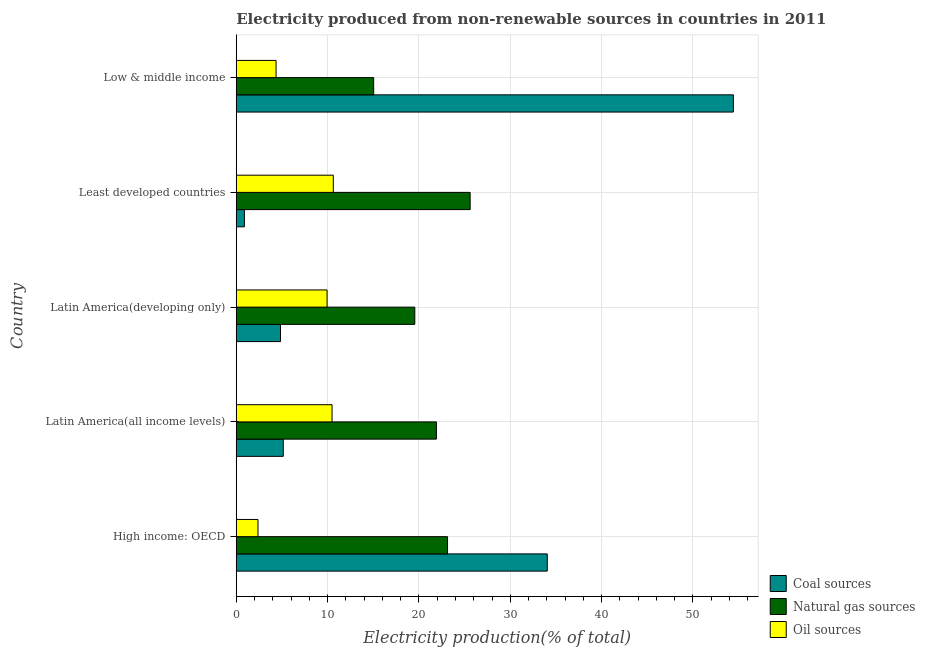How many different coloured bars are there?
Your answer should be compact. 3. How many bars are there on the 3rd tick from the bottom?
Your answer should be very brief. 3. What is the label of the 4th group of bars from the top?
Provide a short and direct response. Latin America(all income levels). What is the percentage of electricity produced by coal in Latin America(all income levels)?
Provide a succinct answer. 5.15. Across all countries, what is the maximum percentage of electricity produced by natural gas?
Your answer should be very brief. 25.61. Across all countries, what is the minimum percentage of electricity produced by natural gas?
Your response must be concise. 15.04. In which country was the percentage of electricity produced by natural gas maximum?
Your response must be concise. Least developed countries. In which country was the percentage of electricity produced by oil sources minimum?
Your response must be concise. High income: OECD. What is the total percentage of electricity produced by oil sources in the graph?
Provide a succinct answer. 37.79. What is the difference between the percentage of electricity produced by coal in Latin America(all income levels) and that in Low & middle income?
Provide a succinct answer. -49.28. What is the difference between the percentage of electricity produced by oil sources in Latin America(developing only) and the percentage of electricity produced by coal in Latin America(all income levels)?
Ensure brevity in your answer.  4.79. What is the average percentage of electricity produced by natural gas per country?
Offer a terse response. 21.05. What is the difference between the percentage of electricity produced by natural gas and percentage of electricity produced by coal in Low & middle income?
Keep it short and to the point. -39.38. What is the ratio of the percentage of electricity produced by natural gas in Latin America(all income levels) to that in Low & middle income?
Provide a short and direct response. 1.46. Is the percentage of electricity produced by natural gas in Latin America(all income levels) less than that in Least developed countries?
Provide a succinct answer. Yes. Is the difference between the percentage of electricity produced by natural gas in High income: OECD and Latin America(all income levels) greater than the difference between the percentage of electricity produced by oil sources in High income: OECD and Latin America(all income levels)?
Your answer should be compact. Yes. What is the difference between the highest and the second highest percentage of electricity produced by natural gas?
Keep it short and to the point. 2.48. What is the difference between the highest and the lowest percentage of electricity produced by natural gas?
Provide a short and direct response. 10.56. In how many countries, is the percentage of electricity produced by natural gas greater than the average percentage of electricity produced by natural gas taken over all countries?
Your answer should be compact. 3. Is the sum of the percentage of electricity produced by oil sources in Latin America(all income levels) and Latin America(developing only) greater than the maximum percentage of electricity produced by natural gas across all countries?
Offer a very short reply. No. What does the 1st bar from the top in Low & middle income represents?
Offer a very short reply. Oil sources. What does the 2nd bar from the bottom in High income: OECD represents?
Make the answer very short. Natural gas sources. How many bars are there?
Ensure brevity in your answer.  15. Are all the bars in the graph horizontal?
Offer a very short reply. Yes. How many countries are there in the graph?
Give a very brief answer. 5. What is the difference between two consecutive major ticks on the X-axis?
Ensure brevity in your answer.  10. Are the values on the major ticks of X-axis written in scientific E-notation?
Offer a very short reply. No. Does the graph contain grids?
Provide a succinct answer. Yes. How are the legend labels stacked?
Ensure brevity in your answer.  Vertical. What is the title of the graph?
Offer a very short reply. Electricity produced from non-renewable sources in countries in 2011. What is the label or title of the X-axis?
Offer a terse response. Electricity production(% of total). What is the label or title of the Y-axis?
Provide a short and direct response. Country. What is the Electricity production(% of total) of Coal sources in High income: OECD?
Provide a short and direct response. 34.05. What is the Electricity production(% of total) of Natural gas sources in High income: OECD?
Offer a very short reply. 23.13. What is the Electricity production(% of total) in Oil sources in High income: OECD?
Offer a very short reply. 2.38. What is the Electricity production(% of total) of Coal sources in Latin America(all income levels)?
Offer a very short reply. 5.15. What is the Electricity production(% of total) in Natural gas sources in Latin America(all income levels)?
Provide a short and direct response. 21.91. What is the Electricity production(% of total) in Oil sources in Latin America(all income levels)?
Your answer should be compact. 10.49. What is the Electricity production(% of total) in Coal sources in Latin America(developing only)?
Your answer should be very brief. 4.84. What is the Electricity production(% of total) in Natural gas sources in Latin America(developing only)?
Provide a short and direct response. 19.55. What is the Electricity production(% of total) in Oil sources in Latin America(developing only)?
Provide a short and direct response. 9.94. What is the Electricity production(% of total) in Coal sources in Least developed countries?
Make the answer very short. 0.89. What is the Electricity production(% of total) in Natural gas sources in Least developed countries?
Your answer should be very brief. 25.61. What is the Electricity production(% of total) of Oil sources in Least developed countries?
Offer a terse response. 10.63. What is the Electricity production(% of total) in Coal sources in Low & middle income?
Offer a very short reply. 54.43. What is the Electricity production(% of total) of Natural gas sources in Low & middle income?
Provide a succinct answer. 15.04. What is the Electricity production(% of total) in Oil sources in Low & middle income?
Offer a very short reply. 4.36. Across all countries, what is the maximum Electricity production(% of total) in Coal sources?
Ensure brevity in your answer.  54.43. Across all countries, what is the maximum Electricity production(% of total) in Natural gas sources?
Provide a succinct answer. 25.61. Across all countries, what is the maximum Electricity production(% of total) in Oil sources?
Offer a terse response. 10.63. Across all countries, what is the minimum Electricity production(% of total) of Coal sources?
Offer a very short reply. 0.89. Across all countries, what is the minimum Electricity production(% of total) in Natural gas sources?
Keep it short and to the point. 15.04. Across all countries, what is the minimum Electricity production(% of total) of Oil sources?
Provide a short and direct response. 2.38. What is the total Electricity production(% of total) in Coal sources in the graph?
Keep it short and to the point. 99.36. What is the total Electricity production(% of total) in Natural gas sources in the graph?
Give a very brief answer. 105.24. What is the total Electricity production(% of total) of Oil sources in the graph?
Ensure brevity in your answer.  37.79. What is the difference between the Electricity production(% of total) of Coal sources in High income: OECD and that in Latin America(all income levels)?
Make the answer very short. 28.9. What is the difference between the Electricity production(% of total) of Natural gas sources in High income: OECD and that in Latin America(all income levels)?
Your answer should be very brief. 1.22. What is the difference between the Electricity production(% of total) of Oil sources in High income: OECD and that in Latin America(all income levels)?
Give a very brief answer. -8.11. What is the difference between the Electricity production(% of total) of Coal sources in High income: OECD and that in Latin America(developing only)?
Ensure brevity in your answer.  29.21. What is the difference between the Electricity production(% of total) in Natural gas sources in High income: OECD and that in Latin America(developing only)?
Make the answer very short. 3.58. What is the difference between the Electricity production(% of total) of Oil sources in High income: OECD and that in Latin America(developing only)?
Your answer should be very brief. -7.56. What is the difference between the Electricity production(% of total) in Coal sources in High income: OECD and that in Least developed countries?
Your answer should be very brief. 33.16. What is the difference between the Electricity production(% of total) of Natural gas sources in High income: OECD and that in Least developed countries?
Provide a short and direct response. -2.48. What is the difference between the Electricity production(% of total) of Oil sources in High income: OECD and that in Least developed countries?
Provide a short and direct response. -8.25. What is the difference between the Electricity production(% of total) in Coal sources in High income: OECD and that in Low & middle income?
Provide a succinct answer. -20.37. What is the difference between the Electricity production(% of total) of Natural gas sources in High income: OECD and that in Low & middle income?
Your answer should be very brief. 8.09. What is the difference between the Electricity production(% of total) of Oil sources in High income: OECD and that in Low & middle income?
Ensure brevity in your answer.  -1.98. What is the difference between the Electricity production(% of total) of Coal sources in Latin America(all income levels) and that in Latin America(developing only)?
Offer a very short reply. 0.3. What is the difference between the Electricity production(% of total) of Natural gas sources in Latin America(all income levels) and that in Latin America(developing only)?
Offer a very short reply. 2.37. What is the difference between the Electricity production(% of total) of Oil sources in Latin America(all income levels) and that in Latin America(developing only)?
Offer a very short reply. 0.55. What is the difference between the Electricity production(% of total) of Coal sources in Latin America(all income levels) and that in Least developed countries?
Offer a terse response. 4.26. What is the difference between the Electricity production(% of total) in Natural gas sources in Latin America(all income levels) and that in Least developed countries?
Provide a succinct answer. -3.69. What is the difference between the Electricity production(% of total) in Oil sources in Latin America(all income levels) and that in Least developed countries?
Offer a terse response. -0.14. What is the difference between the Electricity production(% of total) in Coal sources in Latin America(all income levels) and that in Low & middle income?
Offer a very short reply. -49.28. What is the difference between the Electricity production(% of total) in Natural gas sources in Latin America(all income levels) and that in Low & middle income?
Ensure brevity in your answer.  6.87. What is the difference between the Electricity production(% of total) in Oil sources in Latin America(all income levels) and that in Low & middle income?
Your answer should be very brief. 6.13. What is the difference between the Electricity production(% of total) in Coal sources in Latin America(developing only) and that in Least developed countries?
Your answer should be compact. 3.95. What is the difference between the Electricity production(% of total) of Natural gas sources in Latin America(developing only) and that in Least developed countries?
Offer a terse response. -6.06. What is the difference between the Electricity production(% of total) of Oil sources in Latin America(developing only) and that in Least developed countries?
Make the answer very short. -0.68. What is the difference between the Electricity production(% of total) of Coal sources in Latin America(developing only) and that in Low & middle income?
Your response must be concise. -49.58. What is the difference between the Electricity production(% of total) of Natural gas sources in Latin America(developing only) and that in Low & middle income?
Your answer should be very brief. 4.5. What is the difference between the Electricity production(% of total) of Oil sources in Latin America(developing only) and that in Low & middle income?
Give a very brief answer. 5.58. What is the difference between the Electricity production(% of total) in Coal sources in Least developed countries and that in Low & middle income?
Your answer should be compact. -53.53. What is the difference between the Electricity production(% of total) of Natural gas sources in Least developed countries and that in Low & middle income?
Offer a very short reply. 10.56. What is the difference between the Electricity production(% of total) in Oil sources in Least developed countries and that in Low & middle income?
Your response must be concise. 6.27. What is the difference between the Electricity production(% of total) in Coal sources in High income: OECD and the Electricity production(% of total) in Natural gas sources in Latin America(all income levels)?
Your answer should be very brief. 12.14. What is the difference between the Electricity production(% of total) of Coal sources in High income: OECD and the Electricity production(% of total) of Oil sources in Latin America(all income levels)?
Offer a very short reply. 23.56. What is the difference between the Electricity production(% of total) in Natural gas sources in High income: OECD and the Electricity production(% of total) in Oil sources in Latin America(all income levels)?
Provide a succinct answer. 12.64. What is the difference between the Electricity production(% of total) in Coal sources in High income: OECD and the Electricity production(% of total) in Natural gas sources in Latin America(developing only)?
Make the answer very short. 14.5. What is the difference between the Electricity production(% of total) of Coal sources in High income: OECD and the Electricity production(% of total) of Oil sources in Latin America(developing only)?
Your response must be concise. 24.11. What is the difference between the Electricity production(% of total) in Natural gas sources in High income: OECD and the Electricity production(% of total) in Oil sources in Latin America(developing only)?
Give a very brief answer. 13.19. What is the difference between the Electricity production(% of total) of Coal sources in High income: OECD and the Electricity production(% of total) of Natural gas sources in Least developed countries?
Provide a short and direct response. 8.44. What is the difference between the Electricity production(% of total) in Coal sources in High income: OECD and the Electricity production(% of total) in Oil sources in Least developed countries?
Your response must be concise. 23.43. What is the difference between the Electricity production(% of total) in Natural gas sources in High income: OECD and the Electricity production(% of total) in Oil sources in Least developed countries?
Offer a terse response. 12.51. What is the difference between the Electricity production(% of total) in Coal sources in High income: OECD and the Electricity production(% of total) in Natural gas sources in Low & middle income?
Provide a succinct answer. 19.01. What is the difference between the Electricity production(% of total) in Coal sources in High income: OECD and the Electricity production(% of total) in Oil sources in Low & middle income?
Your answer should be compact. 29.69. What is the difference between the Electricity production(% of total) in Natural gas sources in High income: OECD and the Electricity production(% of total) in Oil sources in Low & middle income?
Your response must be concise. 18.77. What is the difference between the Electricity production(% of total) of Coal sources in Latin America(all income levels) and the Electricity production(% of total) of Natural gas sources in Latin America(developing only)?
Make the answer very short. -14.4. What is the difference between the Electricity production(% of total) in Coal sources in Latin America(all income levels) and the Electricity production(% of total) in Oil sources in Latin America(developing only)?
Your answer should be very brief. -4.79. What is the difference between the Electricity production(% of total) of Natural gas sources in Latin America(all income levels) and the Electricity production(% of total) of Oil sources in Latin America(developing only)?
Your response must be concise. 11.97. What is the difference between the Electricity production(% of total) of Coal sources in Latin America(all income levels) and the Electricity production(% of total) of Natural gas sources in Least developed countries?
Your answer should be compact. -20.46. What is the difference between the Electricity production(% of total) of Coal sources in Latin America(all income levels) and the Electricity production(% of total) of Oil sources in Least developed countries?
Offer a very short reply. -5.48. What is the difference between the Electricity production(% of total) in Natural gas sources in Latin America(all income levels) and the Electricity production(% of total) in Oil sources in Least developed countries?
Your answer should be compact. 11.29. What is the difference between the Electricity production(% of total) in Coal sources in Latin America(all income levels) and the Electricity production(% of total) in Natural gas sources in Low & middle income?
Your answer should be compact. -9.9. What is the difference between the Electricity production(% of total) in Coal sources in Latin America(all income levels) and the Electricity production(% of total) in Oil sources in Low & middle income?
Provide a succinct answer. 0.79. What is the difference between the Electricity production(% of total) in Natural gas sources in Latin America(all income levels) and the Electricity production(% of total) in Oil sources in Low & middle income?
Offer a very short reply. 17.55. What is the difference between the Electricity production(% of total) in Coal sources in Latin America(developing only) and the Electricity production(% of total) in Natural gas sources in Least developed countries?
Make the answer very short. -20.76. What is the difference between the Electricity production(% of total) in Coal sources in Latin America(developing only) and the Electricity production(% of total) in Oil sources in Least developed countries?
Make the answer very short. -5.78. What is the difference between the Electricity production(% of total) in Natural gas sources in Latin America(developing only) and the Electricity production(% of total) in Oil sources in Least developed countries?
Keep it short and to the point. 8.92. What is the difference between the Electricity production(% of total) of Coal sources in Latin America(developing only) and the Electricity production(% of total) of Natural gas sources in Low & middle income?
Your answer should be very brief. -10.2. What is the difference between the Electricity production(% of total) in Coal sources in Latin America(developing only) and the Electricity production(% of total) in Oil sources in Low & middle income?
Offer a very short reply. 0.49. What is the difference between the Electricity production(% of total) in Natural gas sources in Latin America(developing only) and the Electricity production(% of total) in Oil sources in Low & middle income?
Your answer should be compact. 15.19. What is the difference between the Electricity production(% of total) in Coal sources in Least developed countries and the Electricity production(% of total) in Natural gas sources in Low & middle income?
Provide a short and direct response. -14.15. What is the difference between the Electricity production(% of total) in Coal sources in Least developed countries and the Electricity production(% of total) in Oil sources in Low & middle income?
Keep it short and to the point. -3.47. What is the difference between the Electricity production(% of total) of Natural gas sources in Least developed countries and the Electricity production(% of total) of Oil sources in Low & middle income?
Your response must be concise. 21.25. What is the average Electricity production(% of total) of Coal sources per country?
Your response must be concise. 19.87. What is the average Electricity production(% of total) in Natural gas sources per country?
Keep it short and to the point. 21.05. What is the average Electricity production(% of total) of Oil sources per country?
Your response must be concise. 7.56. What is the difference between the Electricity production(% of total) of Coal sources and Electricity production(% of total) of Natural gas sources in High income: OECD?
Give a very brief answer. 10.92. What is the difference between the Electricity production(% of total) of Coal sources and Electricity production(% of total) of Oil sources in High income: OECD?
Your answer should be compact. 31.67. What is the difference between the Electricity production(% of total) in Natural gas sources and Electricity production(% of total) in Oil sources in High income: OECD?
Offer a terse response. 20.75. What is the difference between the Electricity production(% of total) in Coal sources and Electricity production(% of total) in Natural gas sources in Latin America(all income levels)?
Your answer should be very brief. -16.77. What is the difference between the Electricity production(% of total) in Coal sources and Electricity production(% of total) in Oil sources in Latin America(all income levels)?
Give a very brief answer. -5.34. What is the difference between the Electricity production(% of total) of Natural gas sources and Electricity production(% of total) of Oil sources in Latin America(all income levels)?
Keep it short and to the point. 11.43. What is the difference between the Electricity production(% of total) in Coal sources and Electricity production(% of total) in Natural gas sources in Latin America(developing only)?
Ensure brevity in your answer.  -14.7. What is the difference between the Electricity production(% of total) of Coal sources and Electricity production(% of total) of Oil sources in Latin America(developing only)?
Offer a terse response. -5.1. What is the difference between the Electricity production(% of total) of Natural gas sources and Electricity production(% of total) of Oil sources in Latin America(developing only)?
Keep it short and to the point. 9.61. What is the difference between the Electricity production(% of total) in Coal sources and Electricity production(% of total) in Natural gas sources in Least developed countries?
Make the answer very short. -24.72. What is the difference between the Electricity production(% of total) of Coal sources and Electricity production(% of total) of Oil sources in Least developed countries?
Make the answer very short. -9.73. What is the difference between the Electricity production(% of total) of Natural gas sources and Electricity production(% of total) of Oil sources in Least developed countries?
Provide a short and direct response. 14.98. What is the difference between the Electricity production(% of total) of Coal sources and Electricity production(% of total) of Natural gas sources in Low & middle income?
Provide a short and direct response. 39.38. What is the difference between the Electricity production(% of total) of Coal sources and Electricity production(% of total) of Oil sources in Low & middle income?
Offer a very short reply. 50.07. What is the difference between the Electricity production(% of total) in Natural gas sources and Electricity production(% of total) in Oil sources in Low & middle income?
Your response must be concise. 10.69. What is the ratio of the Electricity production(% of total) of Coal sources in High income: OECD to that in Latin America(all income levels)?
Keep it short and to the point. 6.62. What is the ratio of the Electricity production(% of total) of Natural gas sources in High income: OECD to that in Latin America(all income levels)?
Your answer should be compact. 1.06. What is the ratio of the Electricity production(% of total) of Oil sources in High income: OECD to that in Latin America(all income levels)?
Give a very brief answer. 0.23. What is the ratio of the Electricity production(% of total) in Coal sources in High income: OECD to that in Latin America(developing only)?
Keep it short and to the point. 7.03. What is the ratio of the Electricity production(% of total) in Natural gas sources in High income: OECD to that in Latin America(developing only)?
Provide a short and direct response. 1.18. What is the ratio of the Electricity production(% of total) in Oil sources in High income: OECD to that in Latin America(developing only)?
Your response must be concise. 0.24. What is the ratio of the Electricity production(% of total) of Coal sources in High income: OECD to that in Least developed countries?
Your answer should be very brief. 38.2. What is the ratio of the Electricity production(% of total) in Natural gas sources in High income: OECD to that in Least developed countries?
Give a very brief answer. 0.9. What is the ratio of the Electricity production(% of total) of Oil sources in High income: OECD to that in Least developed countries?
Ensure brevity in your answer.  0.22. What is the ratio of the Electricity production(% of total) of Coal sources in High income: OECD to that in Low & middle income?
Your response must be concise. 0.63. What is the ratio of the Electricity production(% of total) of Natural gas sources in High income: OECD to that in Low & middle income?
Give a very brief answer. 1.54. What is the ratio of the Electricity production(% of total) of Oil sources in High income: OECD to that in Low & middle income?
Provide a succinct answer. 0.55. What is the ratio of the Electricity production(% of total) in Coal sources in Latin America(all income levels) to that in Latin America(developing only)?
Provide a short and direct response. 1.06. What is the ratio of the Electricity production(% of total) of Natural gas sources in Latin America(all income levels) to that in Latin America(developing only)?
Keep it short and to the point. 1.12. What is the ratio of the Electricity production(% of total) of Oil sources in Latin America(all income levels) to that in Latin America(developing only)?
Your response must be concise. 1.05. What is the ratio of the Electricity production(% of total) in Coal sources in Latin America(all income levels) to that in Least developed countries?
Your answer should be compact. 5.77. What is the ratio of the Electricity production(% of total) of Natural gas sources in Latin America(all income levels) to that in Least developed countries?
Provide a short and direct response. 0.86. What is the ratio of the Electricity production(% of total) of Oil sources in Latin America(all income levels) to that in Least developed countries?
Offer a terse response. 0.99. What is the ratio of the Electricity production(% of total) of Coal sources in Latin America(all income levels) to that in Low & middle income?
Ensure brevity in your answer.  0.09. What is the ratio of the Electricity production(% of total) of Natural gas sources in Latin America(all income levels) to that in Low & middle income?
Your response must be concise. 1.46. What is the ratio of the Electricity production(% of total) in Oil sources in Latin America(all income levels) to that in Low & middle income?
Keep it short and to the point. 2.41. What is the ratio of the Electricity production(% of total) in Coal sources in Latin America(developing only) to that in Least developed countries?
Provide a succinct answer. 5.43. What is the ratio of the Electricity production(% of total) of Natural gas sources in Latin America(developing only) to that in Least developed countries?
Offer a very short reply. 0.76. What is the ratio of the Electricity production(% of total) of Oil sources in Latin America(developing only) to that in Least developed countries?
Make the answer very short. 0.94. What is the ratio of the Electricity production(% of total) in Coal sources in Latin America(developing only) to that in Low & middle income?
Your response must be concise. 0.09. What is the ratio of the Electricity production(% of total) of Natural gas sources in Latin America(developing only) to that in Low & middle income?
Your answer should be very brief. 1.3. What is the ratio of the Electricity production(% of total) in Oil sources in Latin America(developing only) to that in Low & middle income?
Your answer should be very brief. 2.28. What is the ratio of the Electricity production(% of total) of Coal sources in Least developed countries to that in Low & middle income?
Your answer should be very brief. 0.02. What is the ratio of the Electricity production(% of total) of Natural gas sources in Least developed countries to that in Low & middle income?
Make the answer very short. 1.7. What is the ratio of the Electricity production(% of total) in Oil sources in Least developed countries to that in Low & middle income?
Your response must be concise. 2.44. What is the difference between the highest and the second highest Electricity production(% of total) of Coal sources?
Ensure brevity in your answer.  20.37. What is the difference between the highest and the second highest Electricity production(% of total) of Natural gas sources?
Make the answer very short. 2.48. What is the difference between the highest and the second highest Electricity production(% of total) of Oil sources?
Your response must be concise. 0.14. What is the difference between the highest and the lowest Electricity production(% of total) in Coal sources?
Ensure brevity in your answer.  53.53. What is the difference between the highest and the lowest Electricity production(% of total) in Natural gas sources?
Ensure brevity in your answer.  10.56. What is the difference between the highest and the lowest Electricity production(% of total) of Oil sources?
Keep it short and to the point. 8.25. 